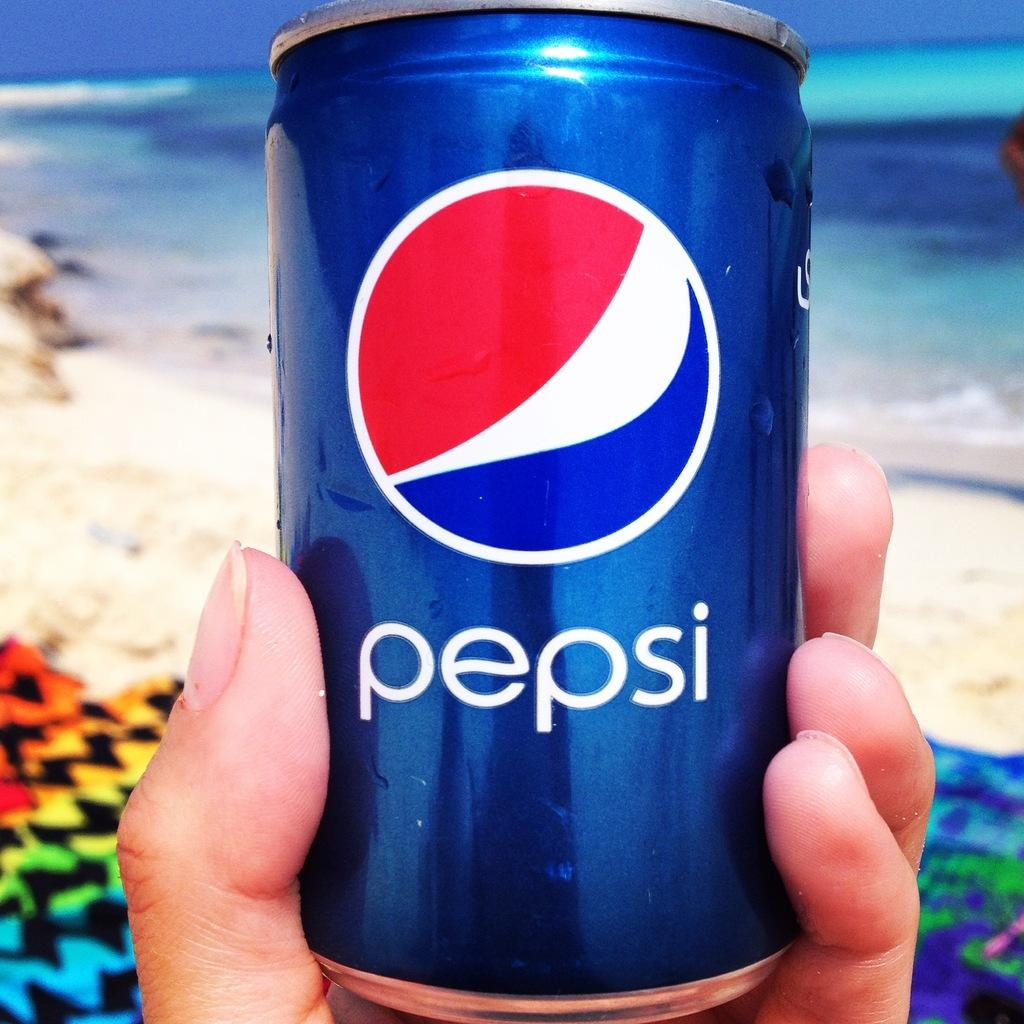<image>
Give a short and clear explanation of the subsequent image. A hand holding a blue can that says pepsi in white letters. 